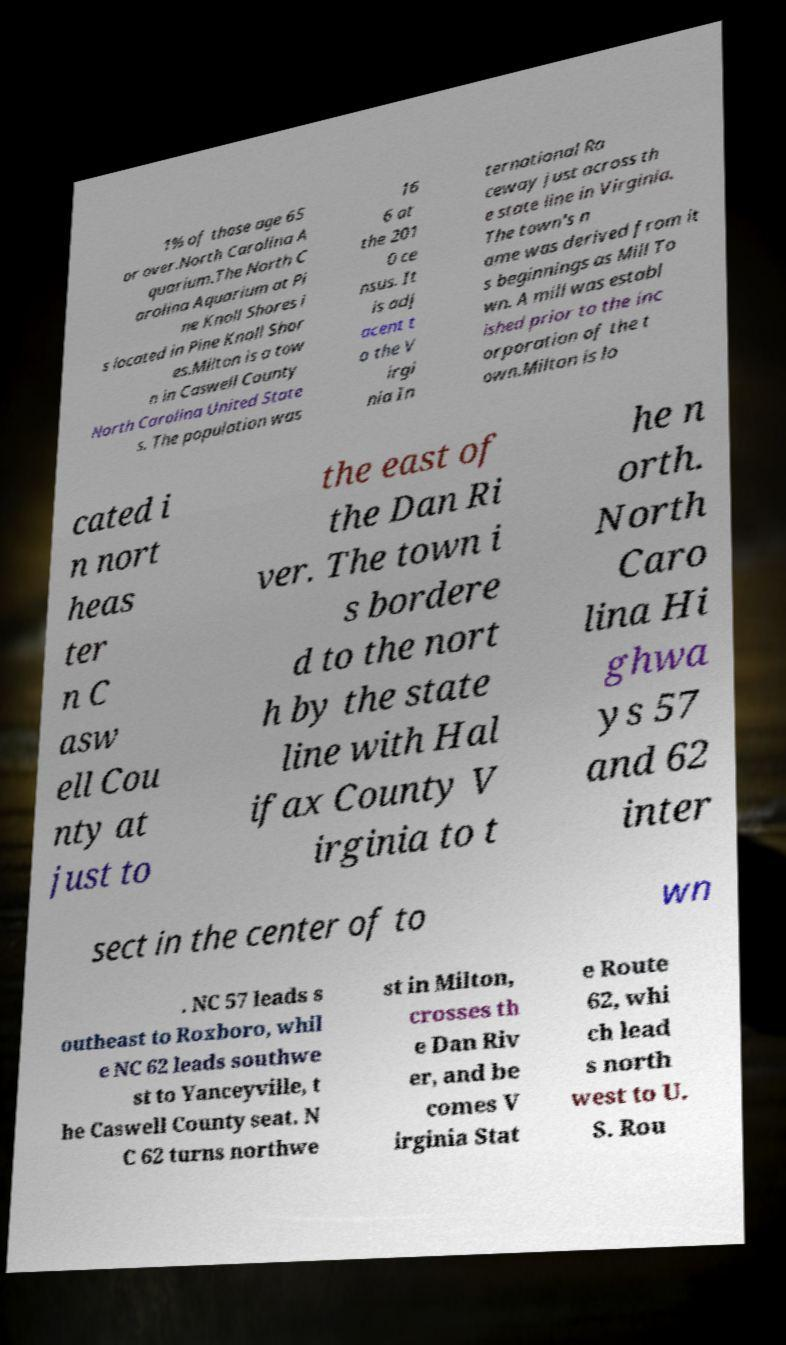Can you read and provide the text displayed in the image?This photo seems to have some interesting text. Can you extract and type it out for me? 1% of those age 65 or over.North Carolina A quarium.The North C arolina Aquarium at Pi ne Knoll Shores i s located in Pine Knoll Shor es.Milton is a tow n in Caswell County North Carolina United State s. The population was 16 6 at the 201 0 ce nsus. It is adj acent t o the V irgi nia In ternational Ra ceway just across th e state line in Virginia. The town's n ame was derived from it s beginnings as Mill To wn. A mill was establ ished prior to the inc orporation of the t own.Milton is lo cated i n nort heas ter n C asw ell Cou nty at just to the east of the Dan Ri ver. The town i s bordere d to the nort h by the state line with Hal ifax County V irginia to t he n orth. North Caro lina Hi ghwa ys 57 and 62 inter sect in the center of to wn . NC 57 leads s outheast to Roxboro, whil e NC 62 leads southwe st to Yanceyville, t he Caswell County seat. N C 62 turns northwe st in Milton, crosses th e Dan Riv er, and be comes V irginia Stat e Route 62, whi ch lead s north west to U. S. Rou 